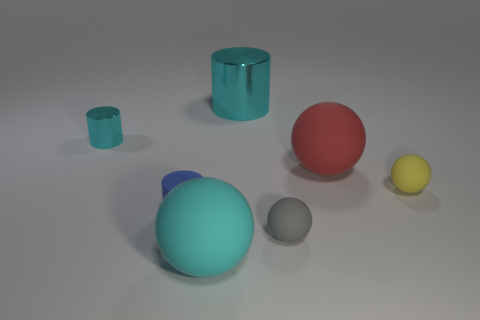There is a gray rubber object; does it have the same shape as the metallic object left of the blue matte cylinder? no 